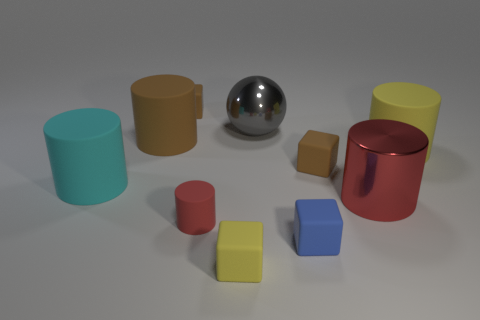Do the small red thing and the small brown thing to the left of the large ball have the same material?
Your answer should be very brief. Yes. What material is the brown object that is the same shape as the tiny red object?
Your answer should be compact. Rubber. Is the number of small things behind the big red shiny cylinder greater than the number of large rubber things to the right of the gray thing?
Make the answer very short. Yes. What shape is the gray thing that is the same material as the big red cylinder?
Provide a succinct answer. Sphere. How many other objects are the same shape as the big red object?
Offer a very short reply. 4. There is a red object behind the red matte cylinder; what is its shape?
Your answer should be very brief. Cylinder. What color is the sphere?
Your answer should be compact. Gray. What number of other things are there of the same size as the blue matte thing?
Keep it short and to the point. 4. There is a tiny object behind the big matte thing that is behind the large yellow cylinder; what is its material?
Your response must be concise. Rubber. There is a metal cylinder; is its size the same as the metallic thing that is on the left side of the blue object?
Keep it short and to the point. Yes. 